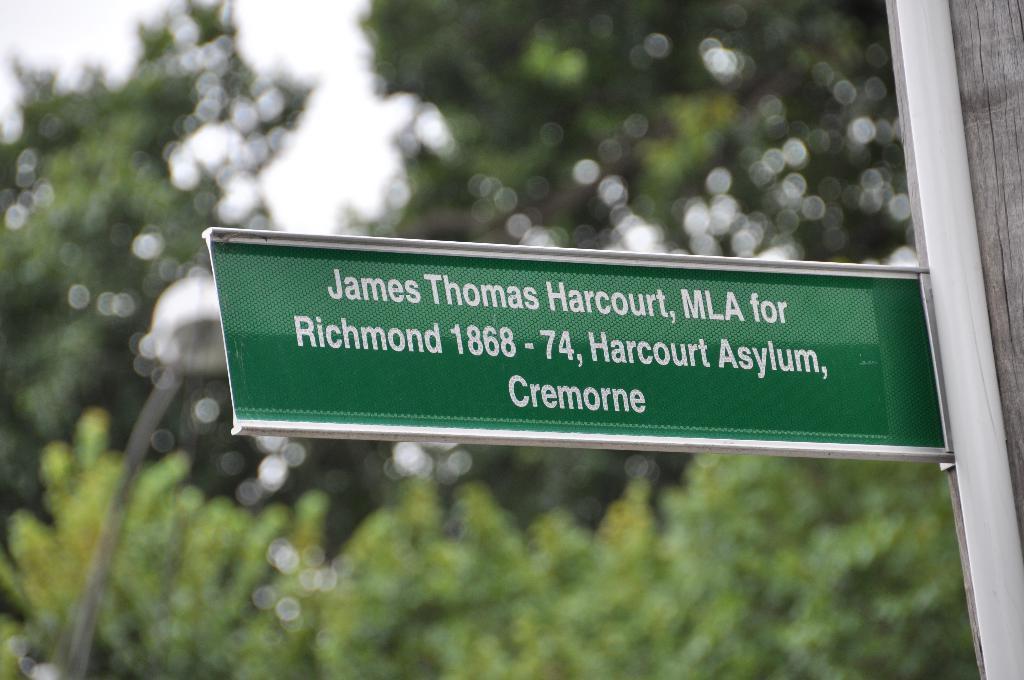Describe this image in one or two sentences. In the image there is some address board attached to a pole and the background of the board is blurry. 